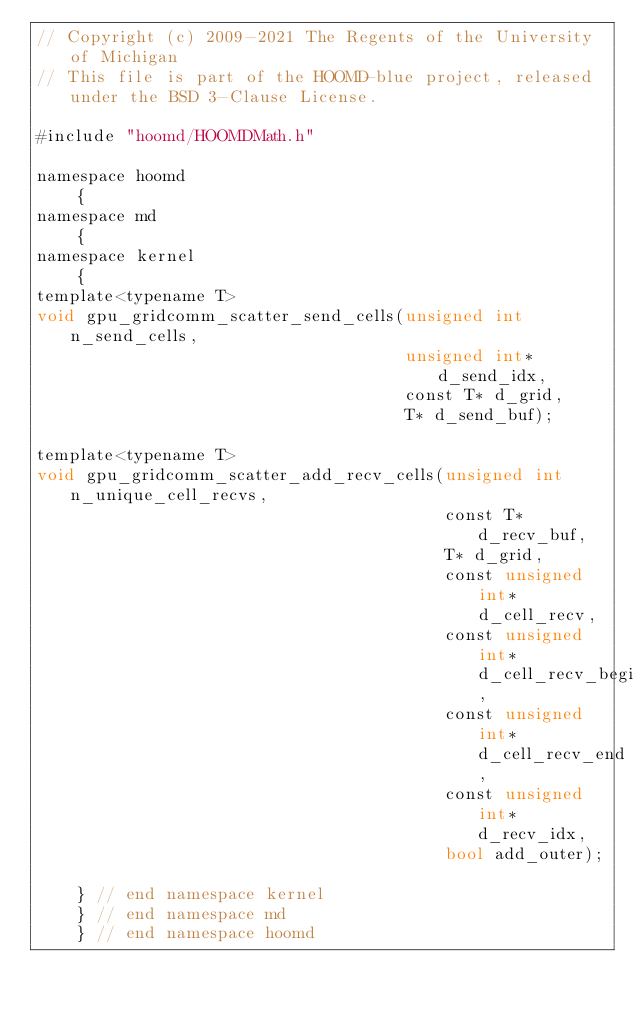Convert code to text. <code><loc_0><loc_0><loc_500><loc_500><_Cuda_>// Copyright (c) 2009-2021 The Regents of the University of Michigan
// This file is part of the HOOMD-blue project, released under the BSD 3-Clause License.

#include "hoomd/HOOMDMath.h"

namespace hoomd
    {
namespace md
    {
namespace kernel
    {
template<typename T>
void gpu_gridcomm_scatter_send_cells(unsigned int n_send_cells,
                                     unsigned int* d_send_idx,
                                     const T* d_grid,
                                     T* d_send_buf);

template<typename T>
void gpu_gridcomm_scatter_add_recv_cells(unsigned int n_unique_cell_recvs,
                                         const T* d_recv_buf,
                                         T* d_grid,
                                         const unsigned int* d_cell_recv,
                                         const unsigned int* d_cell_recv_begin,
                                         const unsigned int* d_cell_recv_end,
                                         const unsigned int* d_recv_idx,
                                         bool add_outer);

    } // end namespace kernel
    } // end namespace md
    } // end namespace hoomd
</code> 